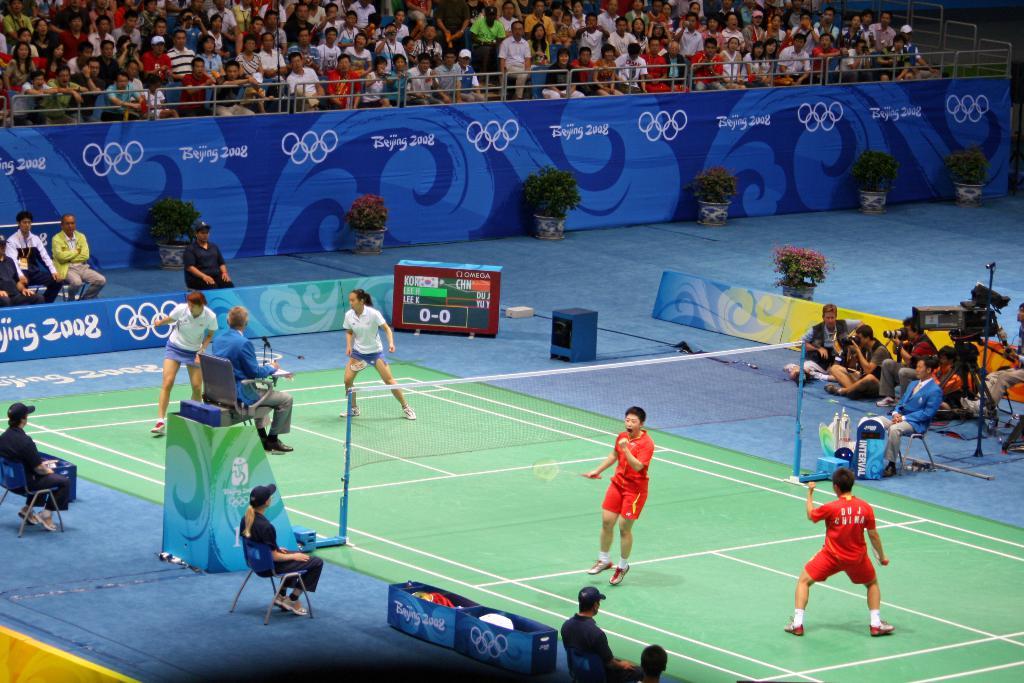What year is this happening in?
Your response must be concise. 2008. 